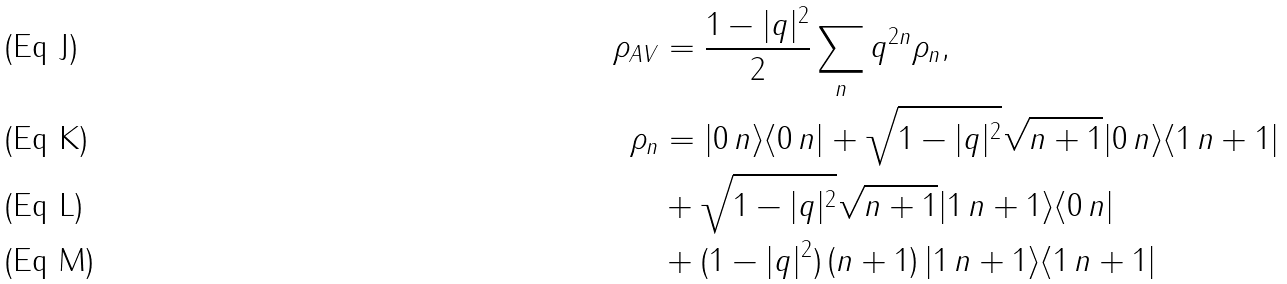<formula> <loc_0><loc_0><loc_500><loc_500>\rho _ { A V } & = \frac { 1 - | q | ^ { 2 } } { 2 } \sum _ { n } q ^ { 2 n } \rho _ { n } , \\ \rho _ { n } & = | 0 \, n \rangle \langle 0 \, n | + \sqrt { 1 - | q | ^ { 2 } } \sqrt { n + 1 } | 0 \, n \rangle \langle 1 \, n + 1 | \\ & + \sqrt { 1 - | q | ^ { 2 } } \sqrt { n + 1 } | 1 \, n + 1 \rangle \langle 0 \, n | \\ & + ( 1 - | q | ^ { 2 } ) \left ( n + 1 \right ) | 1 \, n + 1 \rangle \langle 1 \, n + 1 |</formula> 